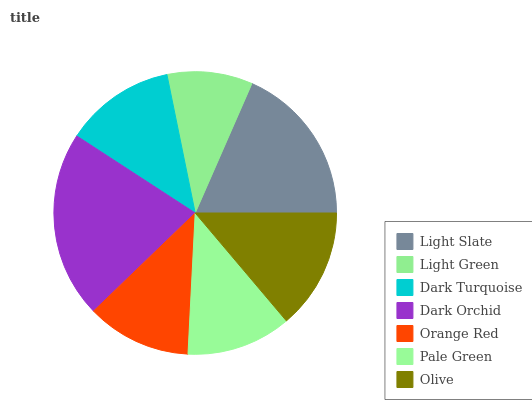Is Light Green the minimum?
Answer yes or no. Yes. Is Dark Orchid the maximum?
Answer yes or no. Yes. Is Dark Turquoise the minimum?
Answer yes or no. No. Is Dark Turquoise the maximum?
Answer yes or no. No. Is Dark Turquoise greater than Light Green?
Answer yes or no. Yes. Is Light Green less than Dark Turquoise?
Answer yes or no. Yes. Is Light Green greater than Dark Turquoise?
Answer yes or no. No. Is Dark Turquoise less than Light Green?
Answer yes or no. No. Is Dark Turquoise the high median?
Answer yes or no. Yes. Is Dark Turquoise the low median?
Answer yes or no. Yes. Is Light Green the high median?
Answer yes or no. No. Is Olive the low median?
Answer yes or no. No. 